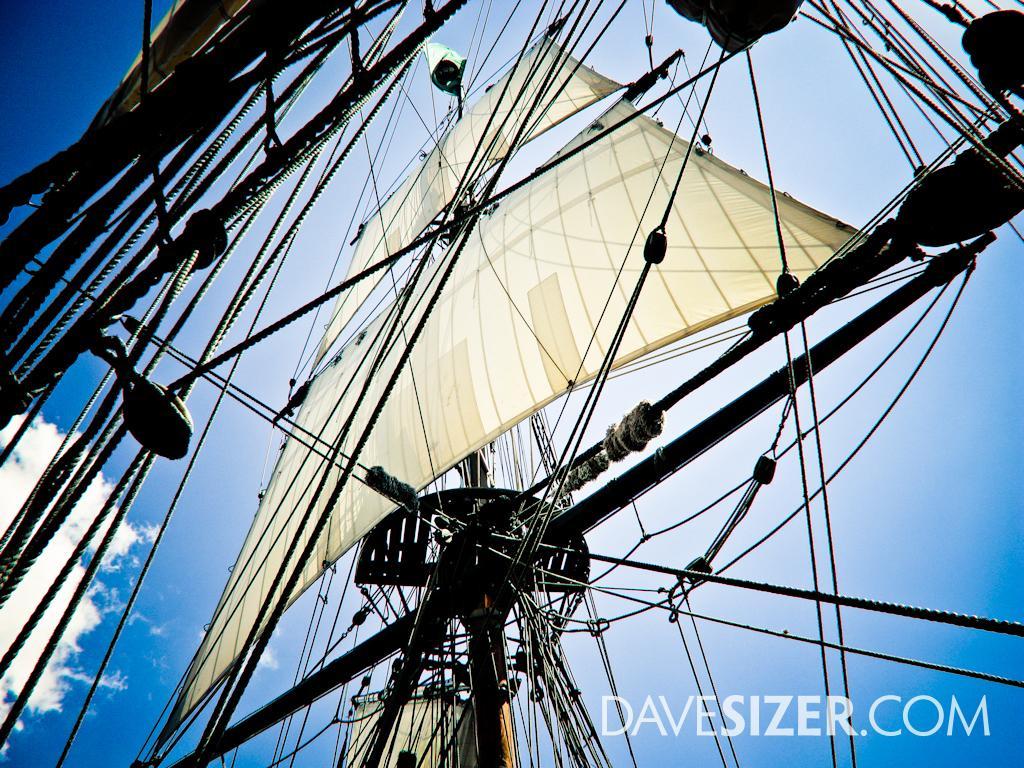Describe this image in one or two sentences. In this image I can see many poles and rods. And I can see the cream color cloth to it. In the back I can see the clouds and the blue sky. 